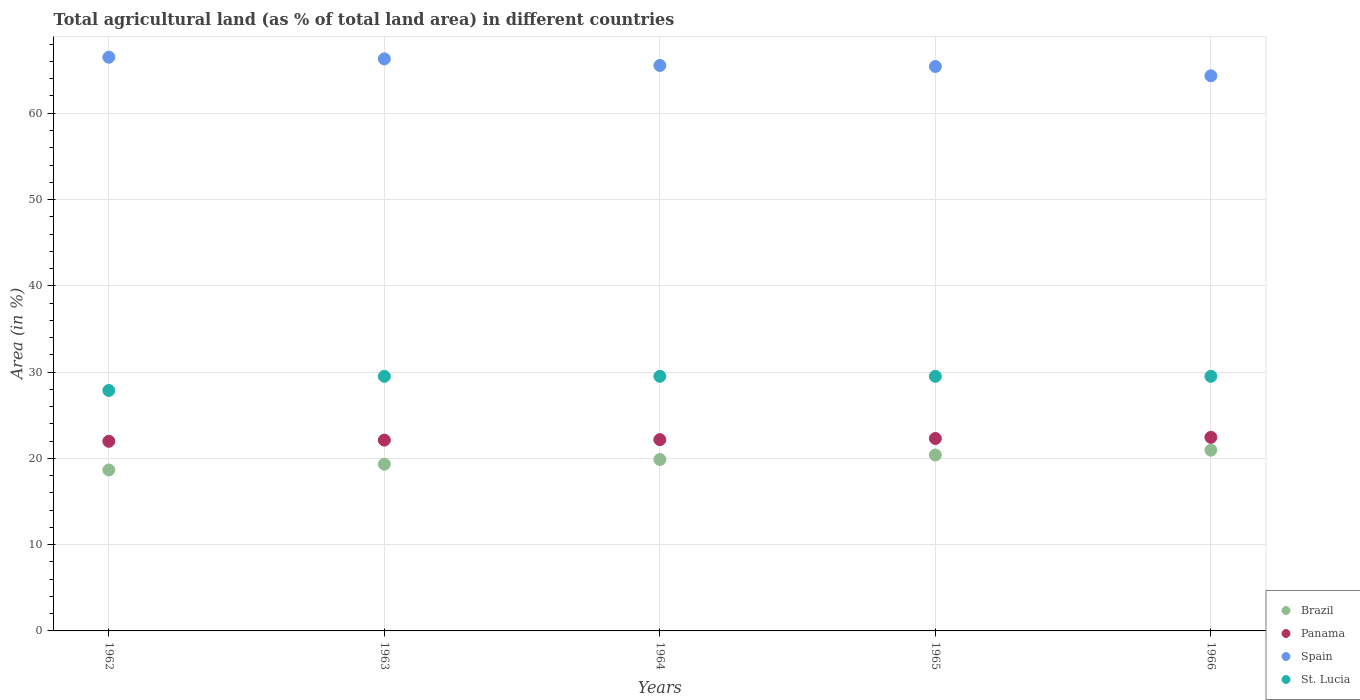How many different coloured dotlines are there?
Your answer should be compact. 4. Is the number of dotlines equal to the number of legend labels?
Offer a terse response. Yes. What is the percentage of agricultural land in Brazil in 1966?
Your response must be concise. 20.95. Across all years, what is the maximum percentage of agricultural land in Panama?
Your answer should be very brief. 22.44. Across all years, what is the minimum percentage of agricultural land in St. Lucia?
Your answer should be compact. 27.87. In which year was the percentage of agricultural land in Brazil maximum?
Provide a succinct answer. 1966. In which year was the percentage of agricultural land in Brazil minimum?
Offer a terse response. 1962. What is the total percentage of agricultural land in Spain in the graph?
Keep it short and to the point. 328.09. What is the difference between the percentage of agricultural land in Spain in 1965 and that in 1966?
Provide a short and direct response. 1.08. What is the difference between the percentage of agricultural land in St. Lucia in 1965 and the percentage of agricultural land in Brazil in 1964?
Your answer should be compact. 9.64. What is the average percentage of agricultural land in St. Lucia per year?
Make the answer very short. 29.18. In the year 1963, what is the difference between the percentage of agricultural land in Spain and percentage of agricultural land in St. Lucia?
Your answer should be compact. 36.79. What is the ratio of the percentage of agricultural land in Brazil in 1965 to that in 1966?
Your answer should be compact. 0.97. Is the percentage of agricultural land in St. Lucia in 1964 less than that in 1966?
Make the answer very short. No. Is the difference between the percentage of agricultural land in Spain in 1963 and 1964 greater than the difference between the percentage of agricultural land in St. Lucia in 1963 and 1964?
Offer a terse response. Yes. What is the difference between the highest and the second highest percentage of agricultural land in Spain?
Your answer should be very brief. 0.19. What is the difference between the highest and the lowest percentage of agricultural land in Brazil?
Make the answer very short. 2.29. Is the sum of the percentage of agricultural land in Panama in 1963 and 1964 greater than the maximum percentage of agricultural land in St. Lucia across all years?
Offer a very short reply. Yes. Is it the case that in every year, the sum of the percentage of agricultural land in St. Lucia and percentage of agricultural land in Brazil  is greater than the sum of percentage of agricultural land in Spain and percentage of agricultural land in Panama?
Offer a terse response. No. Does the percentage of agricultural land in St. Lucia monotonically increase over the years?
Keep it short and to the point. No. Is the percentage of agricultural land in Spain strictly less than the percentage of agricultural land in St. Lucia over the years?
Ensure brevity in your answer.  No. How many years are there in the graph?
Keep it short and to the point. 5. Are the values on the major ticks of Y-axis written in scientific E-notation?
Your answer should be compact. No. Does the graph contain grids?
Make the answer very short. Yes. What is the title of the graph?
Your answer should be compact. Total agricultural land (as % of total land area) in different countries. What is the label or title of the X-axis?
Give a very brief answer. Years. What is the label or title of the Y-axis?
Provide a short and direct response. Area (in %). What is the Area (in %) of Brazil in 1962?
Your answer should be very brief. 18.65. What is the Area (in %) in Panama in 1962?
Offer a terse response. 21.98. What is the Area (in %) in Spain in 1962?
Provide a succinct answer. 66.49. What is the Area (in %) in St. Lucia in 1962?
Your answer should be compact. 27.87. What is the Area (in %) in Brazil in 1963?
Give a very brief answer. 19.32. What is the Area (in %) in Panama in 1963?
Give a very brief answer. 22.11. What is the Area (in %) of Spain in 1963?
Offer a very short reply. 66.3. What is the Area (in %) in St. Lucia in 1963?
Provide a short and direct response. 29.51. What is the Area (in %) in Brazil in 1964?
Keep it short and to the point. 19.87. What is the Area (in %) in Panama in 1964?
Ensure brevity in your answer.  22.17. What is the Area (in %) in Spain in 1964?
Ensure brevity in your answer.  65.53. What is the Area (in %) of St. Lucia in 1964?
Provide a short and direct response. 29.51. What is the Area (in %) of Brazil in 1965?
Keep it short and to the point. 20.39. What is the Area (in %) in Panama in 1965?
Give a very brief answer. 22.3. What is the Area (in %) in Spain in 1965?
Keep it short and to the point. 65.42. What is the Area (in %) in St. Lucia in 1965?
Provide a succinct answer. 29.51. What is the Area (in %) of Brazil in 1966?
Your answer should be compact. 20.95. What is the Area (in %) of Panama in 1966?
Ensure brevity in your answer.  22.44. What is the Area (in %) of Spain in 1966?
Your answer should be very brief. 64.34. What is the Area (in %) in St. Lucia in 1966?
Offer a terse response. 29.51. Across all years, what is the maximum Area (in %) in Brazil?
Give a very brief answer. 20.95. Across all years, what is the maximum Area (in %) of Panama?
Your answer should be compact. 22.44. Across all years, what is the maximum Area (in %) in Spain?
Your answer should be very brief. 66.49. Across all years, what is the maximum Area (in %) of St. Lucia?
Provide a succinct answer. 29.51. Across all years, what is the minimum Area (in %) in Brazil?
Your answer should be compact. 18.65. Across all years, what is the minimum Area (in %) in Panama?
Give a very brief answer. 21.98. Across all years, what is the minimum Area (in %) in Spain?
Your response must be concise. 64.34. Across all years, what is the minimum Area (in %) in St. Lucia?
Your answer should be compact. 27.87. What is the total Area (in %) in Brazil in the graph?
Offer a terse response. 99.18. What is the total Area (in %) in Panama in the graph?
Offer a very short reply. 111. What is the total Area (in %) of Spain in the graph?
Give a very brief answer. 328.09. What is the total Area (in %) in St. Lucia in the graph?
Your answer should be very brief. 145.9. What is the difference between the Area (in %) in Brazil in 1962 and that in 1963?
Your answer should be very brief. -0.67. What is the difference between the Area (in %) in Panama in 1962 and that in 1963?
Your response must be concise. -0.13. What is the difference between the Area (in %) of Spain in 1962 and that in 1963?
Keep it short and to the point. 0.19. What is the difference between the Area (in %) of St. Lucia in 1962 and that in 1963?
Your answer should be compact. -1.64. What is the difference between the Area (in %) in Brazil in 1962 and that in 1964?
Ensure brevity in your answer.  -1.21. What is the difference between the Area (in %) in Panama in 1962 and that in 1964?
Provide a short and direct response. -0.19. What is the difference between the Area (in %) of Spain in 1962 and that in 1964?
Make the answer very short. 0.96. What is the difference between the Area (in %) in St. Lucia in 1962 and that in 1964?
Ensure brevity in your answer.  -1.64. What is the difference between the Area (in %) in Brazil in 1962 and that in 1965?
Offer a terse response. -1.73. What is the difference between the Area (in %) of Panama in 1962 and that in 1965?
Offer a terse response. -0.32. What is the difference between the Area (in %) in Spain in 1962 and that in 1965?
Ensure brevity in your answer.  1.08. What is the difference between the Area (in %) of St. Lucia in 1962 and that in 1965?
Ensure brevity in your answer.  -1.64. What is the difference between the Area (in %) of Brazil in 1962 and that in 1966?
Give a very brief answer. -2.29. What is the difference between the Area (in %) of Panama in 1962 and that in 1966?
Your answer should be compact. -0.46. What is the difference between the Area (in %) in Spain in 1962 and that in 1966?
Keep it short and to the point. 2.15. What is the difference between the Area (in %) of St. Lucia in 1962 and that in 1966?
Give a very brief answer. -1.64. What is the difference between the Area (in %) of Brazil in 1963 and that in 1964?
Your answer should be compact. -0.54. What is the difference between the Area (in %) in Panama in 1963 and that in 1964?
Your response must be concise. -0.05. What is the difference between the Area (in %) of Spain in 1963 and that in 1964?
Offer a very short reply. 0.77. What is the difference between the Area (in %) of Brazil in 1963 and that in 1965?
Make the answer very short. -1.06. What is the difference between the Area (in %) in Panama in 1963 and that in 1965?
Your answer should be very brief. -0.19. What is the difference between the Area (in %) of Spain in 1963 and that in 1965?
Your answer should be very brief. 0.89. What is the difference between the Area (in %) in Brazil in 1963 and that in 1966?
Keep it short and to the point. -1.63. What is the difference between the Area (in %) of Panama in 1963 and that in 1966?
Offer a very short reply. -0.32. What is the difference between the Area (in %) of Spain in 1963 and that in 1966?
Provide a short and direct response. 1.96. What is the difference between the Area (in %) in Brazil in 1964 and that in 1965?
Your answer should be very brief. -0.52. What is the difference between the Area (in %) of Panama in 1964 and that in 1965?
Your answer should be compact. -0.13. What is the difference between the Area (in %) in Spain in 1964 and that in 1965?
Give a very brief answer. 0.12. What is the difference between the Area (in %) in Brazil in 1964 and that in 1966?
Provide a short and direct response. -1.08. What is the difference between the Area (in %) in Panama in 1964 and that in 1966?
Your response must be concise. -0.27. What is the difference between the Area (in %) of Spain in 1964 and that in 1966?
Your response must be concise. 1.19. What is the difference between the Area (in %) of St. Lucia in 1964 and that in 1966?
Make the answer very short. 0. What is the difference between the Area (in %) of Brazil in 1965 and that in 1966?
Give a very brief answer. -0.56. What is the difference between the Area (in %) of Panama in 1965 and that in 1966?
Offer a very short reply. -0.13. What is the difference between the Area (in %) of Spain in 1965 and that in 1966?
Keep it short and to the point. 1.08. What is the difference between the Area (in %) in Brazil in 1962 and the Area (in %) in Panama in 1963?
Offer a very short reply. -3.46. What is the difference between the Area (in %) of Brazil in 1962 and the Area (in %) of Spain in 1963?
Your answer should be compact. -47.65. What is the difference between the Area (in %) in Brazil in 1962 and the Area (in %) in St. Lucia in 1963?
Ensure brevity in your answer.  -10.85. What is the difference between the Area (in %) in Panama in 1962 and the Area (in %) in Spain in 1963?
Provide a short and direct response. -44.32. What is the difference between the Area (in %) of Panama in 1962 and the Area (in %) of St. Lucia in 1963?
Keep it short and to the point. -7.53. What is the difference between the Area (in %) in Spain in 1962 and the Area (in %) in St. Lucia in 1963?
Your response must be concise. 36.99. What is the difference between the Area (in %) in Brazil in 1962 and the Area (in %) in Panama in 1964?
Provide a short and direct response. -3.51. What is the difference between the Area (in %) of Brazil in 1962 and the Area (in %) of Spain in 1964?
Your response must be concise. -46.88. What is the difference between the Area (in %) in Brazil in 1962 and the Area (in %) in St. Lucia in 1964?
Your answer should be compact. -10.85. What is the difference between the Area (in %) of Panama in 1962 and the Area (in %) of Spain in 1964?
Provide a succinct answer. -43.55. What is the difference between the Area (in %) of Panama in 1962 and the Area (in %) of St. Lucia in 1964?
Provide a short and direct response. -7.53. What is the difference between the Area (in %) of Spain in 1962 and the Area (in %) of St. Lucia in 1964?
Your answer should be compact. 36.99. What is the difference between the Area (in %) of Brazil in 1962 and the Area (in %) of Panama in 1965?
Ensure brevity in your answer.  -3.65. What is the difference between the Area (in %) in Brazil in 1962 and the Area (in %) in Spain in 1965?
Your answer should be compact. -46.76. What is the difference between the Area (in %) in Brazil in 1962 and the Area (in %) in St. Lucia in 1965?
Offer a very short reply. -10.85. What is the difference between the Area (in %) in Panama in 1962 and the Area (in %) in Spain in 1965?
Your response must be concise. -43.44. What is the difference between the Area (in %) of Panama in 1962 and the Area (in %) of St. Lucia in 1965?
Ensure brevity in your answer.  -7.53. What is the difference between the Area (in %) of Spain in 1962 and the Area (in %) of St. Lucia in 1965?
Ensure brevity in your answer.  36.99. What is the difference between the Area (in %) of Brazil in 1962 and the Area (in %) of Panama in 1966?
Provide a short and direct response. -3.78. What is the difference between the Area (in %) of Brazil in 1962 and the Area (in %) of Spain in 1966?
Offer a terse response. -45.69. What is the difference between the Area (in %) in Brazil in 1962 and the Area (in %) in St. Lucia in 1966?
Your answer should be compact. -10.85. What is the difference between the Area (in %) in Panama in 1962 and the Area (in %) in Spain in 1966?
Make the answer very short. -42.36. What is the difference between the Area (in %) in Panama in 1962 and the Area (in %) in St. Lucia in 1966?
Your response must be concise. -7.53. What is the difference between the Area (in %) of Spain in 1962 and the Area (in %) of St. Lucia in 1966?
Provide a succinct answer. 36.99. What is the difference between the Area (in %) in Brazil in 1963 and the Area (in %) in Panama in 1964?
Offer a terse response. -2.84. What is the difference between the Area (in %) in Brazil in 1963 and the Area (in %) in Spain in 1964?
Offer a terse response. -46.21. What is the difference between the Area (in %) of Brazil in 1963 and the Area (in %) of St. Lucia in 1964?
Your answer should be very brief. -10.18. What is the difference between the Area (in %) of Panama in 1963 and the Area (in %) of Spain in 1964?
Ensure brevity in your answer.  -43.42. What is the difference between the Area (in %) in Panama in 1963 and the Area (in %) in St. Lucia in 1964?
Your answer should be very brief. -7.39. What is the difference between the Area (in %) in Spain in 1963 and the Area (in %) in St. Lucia in 1964?
Ensure brevity in your answer.  36.8. What is the difference between the Area (in %) in Brazil in 1963 and the Area (in %) in Panama in 1965?
Make the answer very short. -2.98. What is the difference between the Area (in %) in Brazil in 1963 and the Area (in %) in Spain in 1965?
Offer a terse response. -46.09. What is the difference between the Area (in %) of Brazil in 1963 and the Area (in %) of St. Lucia in 1965?
Offer a very short reply. -10.18. What is the difference between the Area (in %) in Panama in 1963 and the Area (in %) in Spain in 1965?
Offer a very short reply. -43.3. What is the difference between the Area (in %) of Panama in 1963 and the Area (in %) of St. Lucia in 1965?
Your response must be concise. -7.39. What is the difference between the Area (in %) in Spain in 1963 and the Area (in %) in St. Lucia in 1965?
Offer a very short reply. 36.8. What is the difference between the Area (in %) in Brazil in 1963 and the Area (in %) in Panama in 1966?
Offer a terse response. -3.11. What is the difference between the Area (in %) of Brazil in 1963 and the Area (in %) of Spain in 1966?
Give a very brief answer. -45.02. What is the difference between the Area (in %) in Brazil in 1963 and the Area (in %) in St. Lucia in 1966?
Ensure brevity in your answer.  -10.18. What is the difference between the Area (in %) of Panama in 1963 and the Area (in %) of Spain in 1966?
Provide a succinct answer. -42.23. What is the difference between the Area (in %) in Panama in 1963 and the Area (in %) in St. Lucia in 1966?
Ensure brevity in your answer.  -7.39. What is the difference between the Area (in %) of Spain in 1963 and the Area (in %) of St. Lucia in 1966?
Offer a terse response. 36.8. What is the difference between the Area (in %) of Brazil in 1964 and the Area (in %) of Panama in 1965?
Offer a very short reply. -2.44. What is the difference between the Area (in %) in Brazil in 1964 and the Area (in %) in Spain in 1965?
Keep it short and to the point. -45.55. What is the difference between the Area (in %) of Brazil in 1964 and the Area (in %) of St. Lucia in 1965?
Your response must be concise. -9.64. What is the difference between the Area (in %) of Panama in 1964 and the Area (in %) of Spain in 1965?
Offer a terse response. -43.25. What is the difference between the Area (in %) of Panama in 1964 and the Area (in %) of St. Lucia in 1965?
Ensure brevity in your answer.  -7.34. What is the difference between the Area (in %) of Spain in 1964 and the Area (in %) of St. Lucia in 1965?
Your response must be concise. 36.03. What is the difference between the Area (in %) in Brazil in 1964 and the Area (in %) in Panama in 1966?
Provide a succinct answer. -2.57. What is the difference between the Area (in %) of Brazil in 1964 and the Area (in %) of Spain in 1966?
Ensure brevity in your answer.  -44.47. What is the difference between the Area (in %) of Brazil in 1964 and the Area (in %) of St. Lucia in 1966?
Keep it short and to the point. -9.64. What is the difference between the Area (in %) in Panama in 1964 and the Area (in %) in Spain in 1966?
Make the answer very short. -42.17. What is the difference between the Area (in %) of Panama in 1964 and the Area (in %) of St. Lucia in 1966?
Provide a succinct answer. -7.34. What is the difference between the Area (in %) in Spain in 1964 and the Area (in %) in St. Lucia in 1966?
Give a very brief answer. 36.03. What is the difference between the Area (in %) in Brazil in 1965 and the Area (in %) in Panama in 1966?
Provide a short and direct response. -2.05. What is the difference between the Area (in %) in Brazil in 1965 and the Area (in %) in Spain in 1966?
Your answer should be compact. -43.95. What is the difference between the Area (in %) of Brazil in 1965 and the Area (in %) of St. Lucia in 1966?
Offer a very short reply. -9.12. What is the difference between the Area (in %) in Panama in 1965 and the Area (in %) in Spain in 1966?
Provide a succinct answer. -42.04. What is the difference between the Area (in %) of Panama in 1965 and the Area (in %) of St. Lucia in 1966?
Your answer should be compact. -7.21. What is the difference between the Area (in %) in Spain in 1965 and the Area (in %) in St. Lucia in 1966?
Give a very brief answer. 35.91. What is the average Area (in %) in Brazil per year?
Ensure brevity in your answer.  19.84. What is the average Area (in %) in Panama per year?
Ensure brevity in your answer.  22.2. What is the average Area (in %) in Spain per year?
Ensure brevity in your answer.  65.62. What is the average Area (in %) of St. Lucia per year?
Ensure brevity in your answer.  29.18. In the year 1962, what is the difference between the Area (in %) of Brazil and Area (in %) of Panama?
Ensure brevity in your answer.  -3.33. In the year 1962, what is the difference between the Area (in %) of Brazil and Area (in %) of Spain?
Keep it short and to the point. -47.84. In the year 1962, what is the difference between the Area (in %) of Brazil and Area (in %) of St. Lucia?
Offer a terse response. -9.21. In the year 1962, what is the difference between the Area (in %) of Panama and Area (in %) of Spain?
Offer a terse response. -44.51. In the year 1962, what is the difference between the Area (in %) in Panama and Area (in %) in St. Lucia?
Your response must be concise. -5.89. In the year 1962, what is the difference between the Area (in %) in Spain and Area (in %) in St. Lucia?
Provide a short and direct response. 38.62. In the year 1963, what is the difference between the Area (in %) in Brazil and Area (in %) in Panama?
Give a very brief answer. -2.79. In the year 1963, what is the difference between the Area (in %) of Brazil and Area (in %) of Spain?
Make the answer very short. -46.98. In the year 1963, what is the difference between the Area (in %) of Brazil and Area (in %) of St. Lucia?
Your answer should be compact. -10.18. In the year 1963, what is the difference between the Area (in %) in Panama and Area (in %) in Spain?
Offer a terse response. -44.19. In the year 1963, what is the difference between the Area (in %) of Panama and Area (in %) of St. Lucia?
Provide a succinct answer. -7.39. In the year 1963, what is the difference between the Area (in %) of Spain and Area (in %) of St. Lucia?
Your answer should be compact. 36.8. In the year 1964, what is the difference between the Area (in %) in Brazil and Area (in %) in Panama?
Ensure brevity in your answer.  -2.3. In the year 1964, what is the difference between the Area (in %) in Brazil and Area (in %) in Spain?
Provide a short and direct response. -45.67. In the year 1964, what is the difference between the Area (in %) of Brazil and Area (in %) of St. Lucia?
Your response must be concise. -9.64. In the year 1964, what is the difference between the Area (in %) in Panama and Area (in %) in Spain?
Make the answer very short. -43.37. In the year 1964, what is the difference between the Area (in %) of Panama and Area (in %) of St. Lucia?
Ensure brevity in your answer.  -7.34. In the year 1964, what is the difference between the Area (in %) of Spain and Area (in %) of St. Lucia?
Make the answer very short. 36.03. In the year 1965, what is the difference between the Area (in %) in Brazil and Area (in %) in Panama?
Provide a succinct answer. -1.92. In the year 1965, what is the difference between the Area (in %) in Brazil and Area (in %) in Spain?
Ensure brevity in your answer.  -45.03. In the year 1965, what is the difference between the Area (in %) of Brazil and Area (in %) of St. Lucia?
Give a very brief answer. -9.12. In the year 1965, what is the difference between the Area (in %) of Panama and Area (in %) of Spain?
Offer a terse response. -43.11. In the year 1965, what is the difference between the Area (in %) in Panama and Area (in %) in St. Lucia?
Ensure brevity in your answer.  -7.21. In the year 1965, what is the difference between the Area (in %) in Spain and Area (in %) in St. Lucia?
Ensure brevity in your answer.  35.91. In the year 1966, what is the difference between the Area (in %) of Brazil and Area (in %) of Panama?
Keep it short and to the point. -1.49. In the year 1966, what is the difference between the Area (in %) in Brazil and Area (in %) in Spain?
Give a very brief answer. -43.39. In the year 1966, what is the difference between the Area (in %) of Brazil and Area (in %) of St. Lucia?
Provide a succinct answer. -8.56. In the year 1966, what is the difference between the Area (in %) of Panama and Area (in %) of Spain?
Your answer should be compact. -41.9. In the year 1966, what is the difference between the Area (in %) in Panama and Area (in %) in St. Lucia?
Your response must be concise. -7.07. In the year 1966, what is the difference between the Area (in %) of Spain and Area (in %) of St. Lucia?
Provide a succinct answer. 34.83. What is the ratio of the Area (in %) in Brazil in 1962 to that in 1963?
Make the answer very short. 0.97. What is the ratio of the Area (in %) of Panama in 1962 to that in 1963?
Offer a very short reply. 0.99. What is the ratio of the Area (in %) in Brazil in 1962 to that in 1964?
Offer a very short reply. 0.94. What is the ratio of the Area (in %) in Spain in 1962 to that in 1964?
Provide a short and direct response. 1.01. What is the ratio of the Area (in %) in Brazil in 1962 to that in 1965?
Your answer should be very brief. 0.92. What is the ratio of the Area (in %) in Panama in 1962 to that in 1965?
Ensure brevity in your answer.  0.99. What is the ratio of the Area (in %) in Spain in 1962 to that in 1965?
Provide a succinct answer. 1.02. What is the ratio of the Area (in %) of Brazil in 1962 to that in 1966?
Make the answer very short. 0.89. What is the ratio of the Area (in %) of Panama in 1962 to that in 1966?
Make the answer very short. 0.98. What is the ratio of the Area (in %) in Spain in 1962 to that in 1966?
Offer a terse response. 1.03. What is the ratio of the Area (in %) of Brazil in 1963 to that in 1964?
Offer a terse response. 0.97. What is the ratio of the Area (in %) in Spain in 1963 to that in 1964?
Ensure brevity in your answer.  1.01. What is the ratio of the Area (in %) of St. Lucia in 1963 to that in 1964?
Your response must be concise. 1. What is the ratio of the Area (in %) of Brazil in 1963 to that in 1965?
Provide a short and direct response. 0.95. What is the ratio of the Area (in %) of Spain in 1963 to that in 1965?
Offer a terse response. 1.01. What is the ratio of the Area (in %) in Brazil in 1963 to that in 1966?
Ensure brevity in your answer.  0.92. What is the ratio of the Area (in %) of Panama in 1963 to that in 1966?
Your response must be concise. 0.99. What is the ratio of the Area (in %) in Spain in 1963 to that in 1966?
Provide a short and direct response. 1.03. What is the ratio of the Area (in %) in St. Lucia in 1963 to that in 1966?
Offer a very short reply. 1. What is the ratio of the Area (in %) of Brazil in 1964 to that in 1965?
Keep it short and to the point. 0.97. What is the ratio of the Area (in %) in St. Lucia in 1964 to that in 1965?
Your response must be concise. 1. What is the ratio of the Area (in %) of Brazil in 1964 to that in 1966?
Make the answer very short. 0.95. What is the ratio of the Area (in %) of Panama in 1964 to that in 1966?
Keep it short and to the point. 0.99. What is the ratio of the Area (in %) in Spain in 1964 to that in 1966?
Ensure brevity in your answer.  1.02. What is the ratio of the Area (in %) in Brazil in 1965 to that in 1966?
Provide a short and direct response. 0.97. What is the ratio of the Area (in %) of Panama in 1965 to that in 1966?
Give a very brief answer. 0.99. What is the ratio of the Area (in %) of Spain in 1965 to that in 1966?
Provide a short and direct response. 1.02. What is the difference between the highest and the second highest Area (in %) of Brazil?
Offer a terse response. 0.56. What is the difference between the highest and the second highest Area (in %) in Panama?
Your answer should be very brief. 0.13. What is the difference between the highest and the second highest Area (in %) in Spain?
Provide a succinct answer. 0.19. What is the difference between the highest and the second highest Area (in %) in St. Lucia?
Your answer should be compact. 0. What is the difference between the highest and the lowest Area (in %) of Brazil?
Make the answer very short. 2.29. What is the difference between the highest and the lowest Area (in %) of Panama?
Offer a very short reply. 0.46. What is the difference between the highest and the lowest Area (in %) in Spain?
Make the answer very short. 2.15. What is the difference between the highest and the lowest Area (in %) in St. Lucia?
Keep it short and to the point. 1.64. 